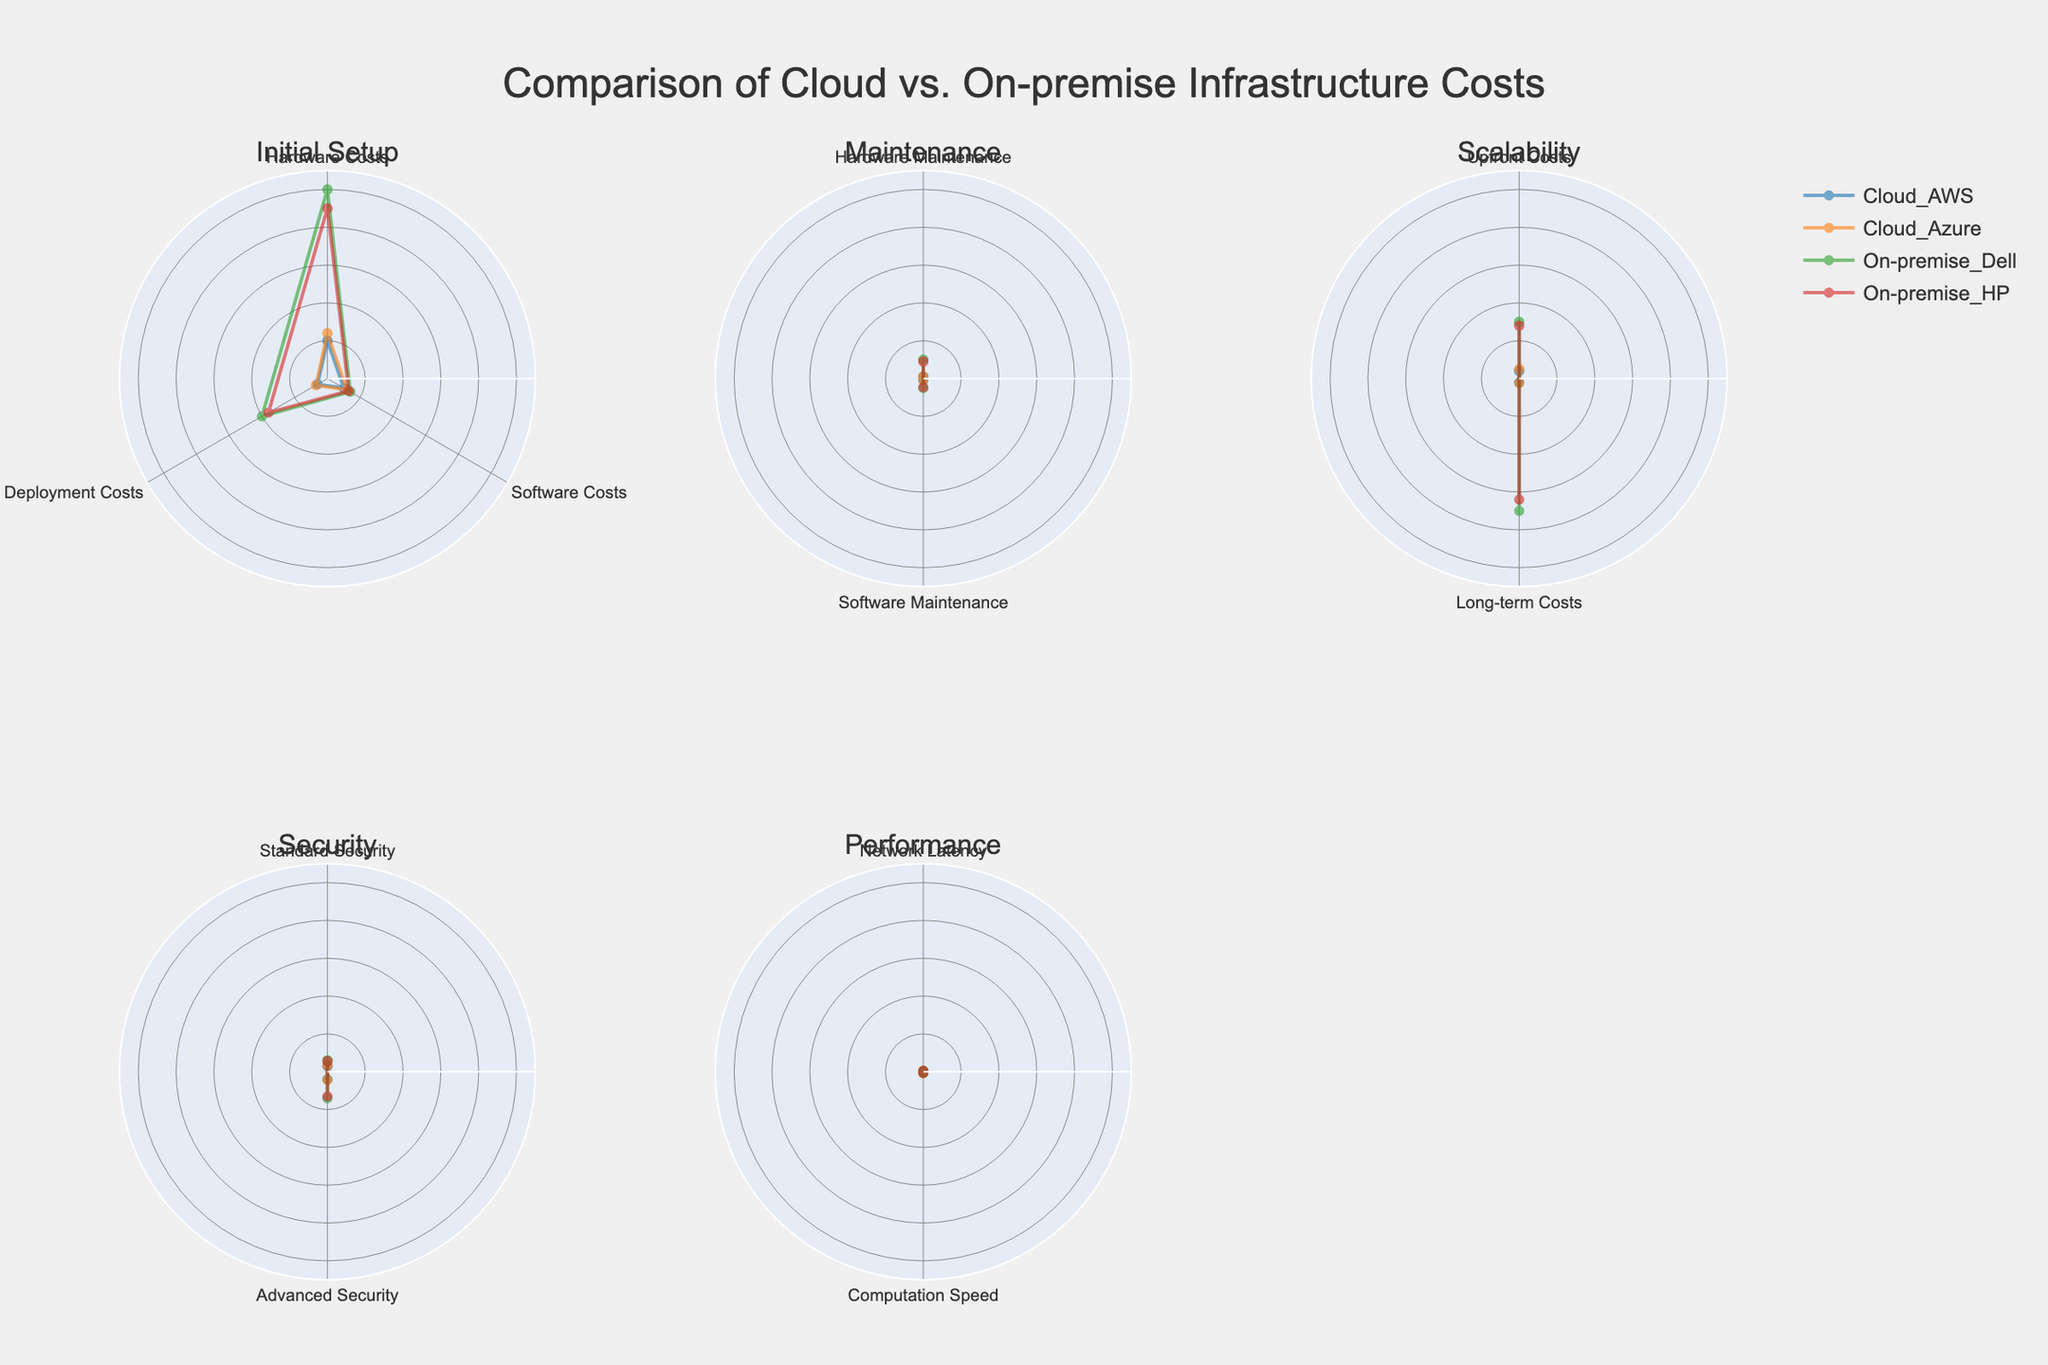What's the title of the figure? The title is located at the top of the figure, which provides an overview of what the figure is about.
Answer: Comparison of Cloud vs. On-premise Infrastructure Costs How many subplots are in the figure? The figure has subplots arranged in a grid format, and each subplot represents a different category of costs. There are 6 radar charts as specified.
Answer: 6 Which provider has the highest initial hardware costs? By reviewing the Initial Setup category in the subplot, we see the values for Hardware Costs for each provider. On-premise Dell has the highest value at 5000.
Answer: On-premise Dell What's the difference in hardware maintenance costs between Cloud AWS and On-premise HP? In the Maintenance category, Cloud AWS has hardware maintenance costs of 50, while On-premise HP has 450. The difference is 450 - 50.
Answer: 400 What is the average software maintenance cost for Cloud providers? The software maintenance costs for Cloud providers (AWS and Azure) are 40 and 45 respectively. Their average is (40 + 45) / 2.
Answer: 42.5 Which provider offers the best performance in network latency? Under the Performance category, the Network Latency values for the providers are compared. On-premise Dell has the lowest value at 15, indicating the best performance.
Answer: On-premise Dell Compare the scalability upfront costs between Cloud AWS and On-premise Dell. Which one is more cost-effective? For Scalability Upfront Costs, Cloud AWS has a value of 200, while On-premise Dell has 1500. Cloud AWS is more cost-effective.
Answer: Cloud AWS What is the total advanced security cost for both Cloud providers? The Advanced Security costs for Cloud AWS and Azure are 200 and 220 respectively. Their total is 200 + 220.
Answer: 420 Which provider has the lowest deployment costs, and what is that cost? In the Initial Setup category, deployment costs for each provider are reviewed. Cloud AWS has the lowest at 300.
Answer: Cloud AWS How does the long-term scalability cost for On-premise HP compare to Cloud Azure? The Long-term Costs for On-premise HP are 3200 and for Cloud Azure are 120. On-premise HP is significantly higher.
Answer: On-premise HP is higher 